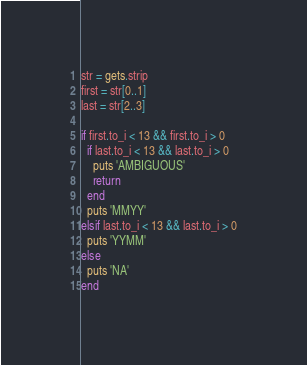Convert code to text. <code><loc_0><loc_0><loc_500><loc_500><_Ruby_>str = gets.strip
first = str[0..1]
last = str[2..3]

if first.to_i < 13 && first.to_i > 0
  if last.to_i < 13 && last.to_i > 0
    puts 'AMBIGUOUS'
    return
  end
  puts 'MMYY'
elsif last.to_i < 13 && last.to_i > 0
  puts 'YYMM'
else
  puts 'NA'
end</code> 